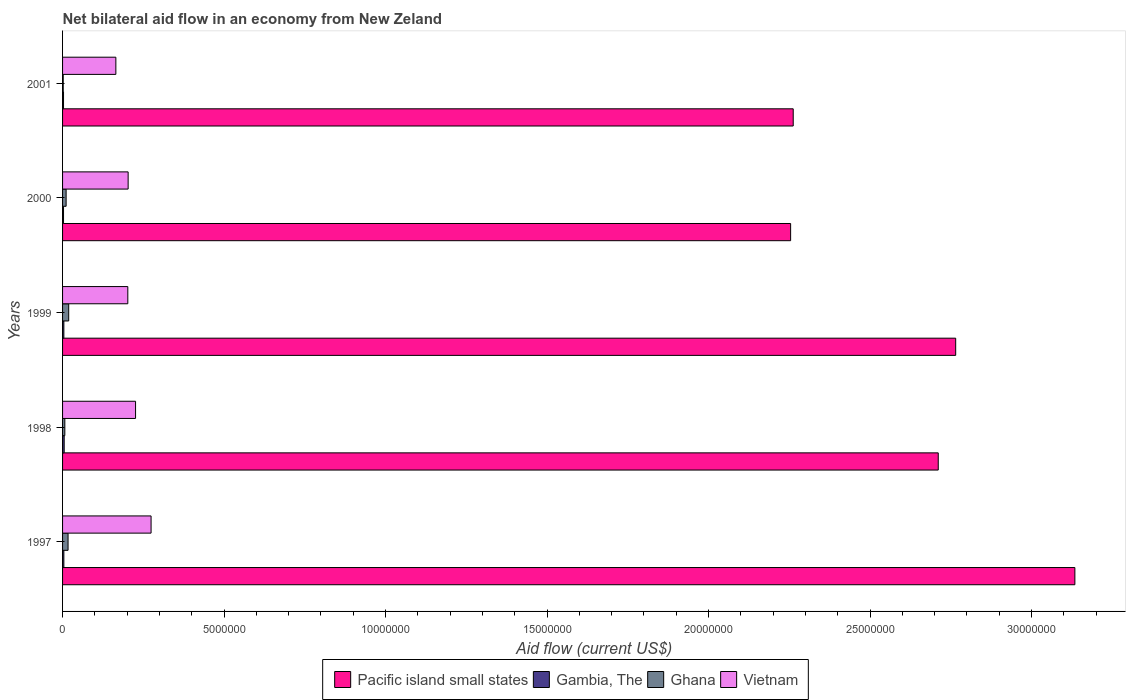How many different coloured bars are there?
Your answer should be very brief. 4. How many groups of bars are there?
Provide a succinct answer. 5. Are the number of bars on each tick of the Y-axis equal?
Offer a terse response. Yes. How many bars are there on the 3rd tick from the top?
Ensure brevity in your answer.  4. In how many cases, is the number of bars for a given year not equal to the number of legend labels?
Provide a short and direct response. 0. What is the net bilateral aid flow in Ghana in 1998?
Provide a short and direct response. 7.00e+04. Across all years, what is the maximum net bilateral aid flow in Vietnam?
Ensure brevity in your answer.  2.74e+06. Across all years, what is the minimum net bilateral aid flow in Pacific island small states?
Provide a short and direct response. 2.25e+07. In which year was the net bilateral aid flow in Ghana maximum?
Ensure brevity in your answer.  1999. What is the total net bilateral aid flow in Vietnam in the graph?
Provide a short and direct response. 1.07e+07. What is the difference between the net bilateral aid flow in Vietnam in 1998 and that in 1999?
Provide a succinct answer. 2.40e+05. What is the difference between the net bilateral aid flow in Pacific island small states in 2000 and the net bilateral aid flow in Vietnam in 1997?
Your answer should be compact. 1.98e+07. What is the average net bilateral aid flow in Pacific island small states per year?
Provide a succinct answer. 2.63e+07. In the year 1998, what is the difference between the net bilateral aid flow in Vietnam and net bilateral aid flow in Gambia, The?
Your response must be concise. 2.21e+06. In how many years, is the net bilateral aid flow in Pacific island small states greater than 21000000 US$?
Give a very brief answer. 5. What is the ratio of the net bilateral aid flow in Gambia, The in 1997 to that in 2001?
Ensure brevity in your answer.  1.33. Is the net bilateral aid flow in Pacific island small states in 1997 less than that in 2001?
Keep it short and to the point. No. What is the difference between the highest and the second highest net bilateral aid flow in Pacific island small states?
Keep it short and to the point. 3.69e+06. Is it the case that in every year, the sum of the net bilateral aid flow in Vietnam and net bilateral aid flow in Gambia, The is greater than the sum of net bilateral aid flow in Pacific island small states and net bilateral aid flow in Ghana?
Ensure brevity in your answer.  Yes. What does the 4th bar from the top in 2001 represents?
Ensure brevity in your answer.  Pacific island small states. What does the 1st bar from the bottom in 2001 represents?
Your answer should be compact. Pacific island small states. Is it the case that in every year, the sum of the net bilateral aid flow in Ghana and net bilateral aid flow in Vietnam is greater than the net bilateral aid flow in Pacific island small states?
Provide a short and direct response. No. How many bars are there?
Offer a very short reply. 20. How many years are there in the graph?
Make the answer very short. 5. What is the difference between two consecutive major ticks on the X-axis?
Your answer should be very brief. 5.00e+06. Does the graph contain grids?
Ensure brevity in your answer.  No. What is the title of the graph?
Your answer should be very brief. Net bilateral aid flow in an economy from New Zeland. Does "Lebanon" appear as one of the legend labels in the graph?
Provide a short and direct response. No. What is the label or title of the X-axis?
Your answer should be compact. Aid flow (current US$). What is the Aid flow (current US$) of Pacific island small states in 1997?
Keep it short and to the point. 3.13e+07. What is the Aid flow (current US$) in Ghana in 1997?
Make the answer very short. 1.70e+05. What is the Aid flow (current US$) in Vietnam in 1997?
Keep it short and to the point. 2.74e+06. What is the Aid flow (current US$) of Pacific island small states in 1998?
Your response must be concise. 2.71e+07. What is the Aid flow (current US$) in Gambia, The in 1998?
Provide a short and direct response. 5.00e+04. What is the Aid flow (current US$) in Ghana in 1998?
Give a very brief answer. 7.00e+04. What is the Aid flow (current US$) in Vietnam in 1998?
Keep it short and to the point. 2.26e+06. What is the Aid flow (current US$) of Pacific island small states in 1999?
Provide a succinct answer. 2.76e+07. What is the Aid flow (current US$) in Ghana in 1999?
Provide a short and direct response. 1.90e+05. What is the Aid flow (current US$) in Vietnam in 1999?
Your response must be concise. 2.02e+06. What is the Aid flow (current US$) in Pacific island small states in 2000?
Give a very brief answer. 2.25e+07. What is the Aid flow (current US$) of Gambia, The in 2000?
Give a very brief answer. 3.00e+04. What is the Aid flow (current US$) in Ghana in 2000?
Make the answer very short. 1.10e+05. What is the Aid flow (current US$) of Vietnam in 2000?
Provide a short and direct response. 2.03e+06. What is the Aid flow (current US$) of Pacific island small states in 2001?
Your answer should be very brief. 2.26e+07. What is the Aid flow (current US$) of Gambia, The in 2001?
Make the answer very short. 3.00e+04. What is the Aid flow (current US$) of Vietnam in 2001?
Provide a succinct answer. 1.65e+06. Across all years, what is the maximum Aid flow (current US$) in Pacific island small states?
Keep it short and to the point. 3.13e+07. Across all years, what is the maximum Aid flow (current US$) in Gambia, The?
Your answer should be compact. 5.00e+04. Across all years, what is the maximum Aid flow (current US$) of Vietnam?
Ensure brevity in your answer.  2.74e+06. Across all years, what is the minimum Aid flow (current US$) of Pacific island small states?
Provide a short and direct response. 2.25e+07. Across all years, what is the minimum Aid flow (current US$) of Gambia, The?
Ensure brevity in your answer.  3.00e+04. Across all years, what is the minimum Aid flow (current US$) of Ghana?
Keep it short and to the point. 2.00e+04. Across all years, what is the minimum Aid flow (current US$) of Vietnam?
Your answer should be very brief. 1.65e+06. What is the total Aid flow (current US$) of Pacific island small states in the graph?
Offer a very short reply. 1.31e+08. What is the total Aid flow (current US$) of Ghana in the graph?
Your answer should be very brief. 5.60e+05. What is the total Aid flow (current US$) of Vietnam in the graph?
Provide a succinct answer. 1.07e+07. What is the difference between the Aid flow (current US$) in Pacific island small states in 1997 and that in 1998?
Give a very brief answer. 4.23e+06. What is the difference between the Aid flow (current US$) in Gambia, The in 1997 and that in 1998?
Give a very brief answer. -10000. What is the difference between the Aid flow (current US$) in Vietnam in 1997 and that in 1998?
Your answer should be compact. 4.80e+05. What is the difference between the Aid flow (current US$) in Pacific island small states in 1997 and that in 1999?
Your response must be concise. 3.69e+06. What is the difference between the Aid flow (current US$) in Vietnam in 1997 and that in 1999?
Make the answer very short. 7.20e+05. What is the difference between the Aid flow (current US$) in Pacific island small states in 1997 and that in 2000?
Make the answer very short. 8.80e+06. What is the difference between the Aid flow (current US$) in Ghana in 1997 and that in 2000?
Give a very brief answer. 6.00e+04. What is the difference between the Aid flow (current US$) in Vietnam in 1997 and that in 2000?
Provide a succinct answer. 7.10e+05. What is the difference between the Aid flow (current US$) of Pacific island small states in 1997 and that in 2001?
Make the answer very short. 8.72e+06. What is the difference between the Aid flow (current US$) in Gambia, The in 1997 and that in 2001?
Offer a very short reply. 10000. What is the difference between the Aid flow (current US$) in Ghana in 1997 and that in 2001?
Give a very brief answer. 1.50e+05. What is the difference between the Aid flow (current US$) in Vietnam in 1997 and that in 2001?
Offer a very short reply. 1.09e+06. What is the difference between the Aid flow (current US$) of Pacific island small states in 1998 and that in 1999?
Make the answer very short. -5.40e+05. What is the difference between the Aid flow (current US$) in Pacific island small states in 1998 and that in 2000?
Ensure brevity in your answer.  4.57e+06. What is the difference between the Aid flow (current US$) in Gambia, The in 1998 and that in 2000?
Your response must be concise. 2.00e+04. What is the difference between the Aid flow (current US$) in Vietnam in 1998 and that in 2000?
Your answer should be compact. 2.30e+05. What is the difference between the Aid flow (current US$) of Pacific island small states in 1998 and that in 2001?
Offer a very short reply. 4.49e+06. What is the difference between the Aid flow (current US$) in Gambia, The in 1998 and that in 2001?
Make the answer very short. 2.00e+04. What is the difference between the Aid flow (current US$) of Ghana in 1998 and that in 2001?
Give a very brief answer. 5.00e+04. What is the difference between the Aid flow (current US$) of Pacific island small states in 1999 and that in 2000?
Your answer should be very brief. 5.11e+06. What is the difference between the Aid flow (current US$) of Ghana in 1999 and that in 2000?
Give a very brief answer. 8.00e+04. What is the difference between the Aid flow (current US$) in Vietnam in 1999 and that in 2000?
Offer a very short reply. -10000. What is the difference between the Aid flow (current US$) of Pacific island small states in 1999 and that in 2001?
Make the answer very short. 5.03e+06. What is the difference between the Aid flow (current US$) in Gambia, The in 1999 and that in 2001?
Offer a very short reply. 10000. What is the difference between the Aid flow (current US$) of Vietnam in 1999 and that in 2001?
Offer a terse response. 3.70e+05. What is the difference between the Aid flow (current US$) in Gambia, The in 2000 and that in 2001?
Your answer should be very brief. 0. What is the difference between the Aid flow (current US$) of Ghana in 2000 and that in 2001?
Your answer should be very brief. 9.00e+04. What is the difference between the Aid flow (current US$) of Pacific island small states in 1997 and the Aid flow (current US$) of Gambia, The in 1998?
Ensure brevity in your answer.  3.13e+07. What is the difference between the Aid flow (current US$) of Pacific island small states in 1997 and the Aid flow (current US$) of Ghana in 1998?
Provide a succinct answer. 3.13e+07. What is the difference between the Aid flow (current US$) of Pacific island small states in 1997 and the Aid flow (current US$) of Vietnam in 1998?
Keep it short and to the point. 2.91e+07. What is the difference between the Aid flow (current US$) of Gambia, The in 1997 and the Aid flow (current US$) of Vietnam in 1998?
Keep it short and to the point. -2.22e+06. What is the difference between the Aid flow (current US$) of Ghana in 1997 and the Aid flow (current US$) of Vietnam in 1998?
Give a very brief answer. -2.09e+06. What is the difference between the Aid flow (current US$) of Pacific island small states in 1997 and the Aid flow (current US$) of Gambia, The in 1999?
Your answer should be compact. 3.13e+07. What is the difference between the Aid flow (current US$) of Pacific island small states in 1997 and the Aid flow (current US$) of Ghana in 1999?
Provide a short and direct response. 3.12e+07. What is the difference between the Aid flow (current US$) in Pacific island small states in 1997 and the Aid flow (current US$) in Vietnam in 1999?
Keep it short and to the point. 2.93e+07. What is the difference between the Aid flow (current US$) in Gambia, The in 1997 and the Aid flow (current US$) in Vietnam in 1999?
Your response must be concise. -1.98e+06. What is the difference between the Aid flow (current US$) of Ghana in 1997 and the Aid flow (current US$) of Vietnam in 1999?
Give a very brief answer. -1.85e+06. What is the difference between the Aid flow (current US$) in Pacific island small states in 1997 and the Aid flow (current US$) in Gambia, The in 2000?
Your answer should be compact. 3.13e+07. What is the difference between the Aid flow (current US$) of Pacific island small states in 1997 and the Aid flow (current US$) of Ghana in 2000?
Give a very brief answer. 3.12e+07. What is the difference between the Aid flow (current US$) of Pacific island small states in 1997 and the Aid flow (current US$) of Vietnam in 2000?
Keep it short and to the point. 2.93e+07. What is the difference between the Aid flow (current US$) in Gambia, The in 1997 and the Aid flow (current US$) in Vietnam in 2000?
Ensure brevity in your answer.  -1.99e+06. What is the difference between the Aid flow (current US$) in Ghana in 1997 and the Aid flow (current US$) in Vietnam in 2000?
Give a very brief answer. -1.86e+06. What is the difference between the Aid flow (current US$) in Pacific island small states in 1997 and the Aid flow (current US$) in Gambia, The in 2001?
Provide a succinct answer. 3.13e+07. What is the difference between the Aid flow (current US$) in Pacific island small states in 1997 and the Aid flow (current US$) in Ghana in 2001?
Offer a very short reply. 3.13e+07. What is the difference between the Aid flow (current US$) of Pacific island small states in 1997 and the Aid flow (current US$) of Vietnam in 2001?
Offer a terse response. 2.97e+07. What is the difference between the Aid flow (current US$) of Gambia, The in 1997 and the Aid flow (current US$) of Vietnam in 2001?
Offer a terse response. -1.61e+06. What is the difference between the Aid flow (current US$) in Ghana in 1997 and the Aid flow (current US$) in Vietnam in 2001?
Provide a short and direct response. -1.48e+06. What is the difference between the Aid flow (current US$) in Pacific island small states in 1998 and the Aid flow (current US$) in Gambia, The in 1999?
Your response must be concise. 2.71e+07. What is the difference between the Aid flow (current US$) in Pacific island small states in 1998 and the Aid flow (current US$) in Ghana in 1999?
Provide a short and direct response. 2.69e+07. What is the difference between the Aid flow (current US$) in Pacific island small states in 1998 and the Aid flow (current US$) in Vietnam in 1999?
Provide a short and direct response. 2.51e+07. What is the difference between the Aid flow (current US$) in Gambia, The in 1998 and the Aid flow (current US$) in Vietnam in 1999?
Keep it short and to the point. -1.97e+06. What is the difference between the Aid flow (current US$) in Ghana in 1998 and the Aid flow (current US$) in Vietnam in 1999?
Offer a terse response. -1.95e+06. What is the difference between the Aid flow (current US$) of Pacific island small states in 1998 and the Aid flow (current US$) of Gambia, The in 2000?
Provide a succinct answer. 2.71e+07. What is the difference between the Aid flow (current US$) in Pacific island small states in 1998 and the Aid flow (current US$) in Ghana in 2000?
Your answer should be very brief. 2.70e+07. What is the difference between the Aid flow (current US$) in Pacific island small states in 1998 and the Aid flow (current US$) in Vietnam in 2000?
Keep it short and to the point. 2.51e+07. What is the difference between the Aid flow (current US$) in Gambia, The in 1998 and the Aid flow (current US$) in Vietnam in 2000?
Your answer should be compact. -1.98e+06. What is the difference between the Aid flow (current US$) of Ghana in 1998 and the Aid flow (current US$) of Vietnam in 2000?
Offer a terse response. -1.96e+06. What is the difference between the Aid flow (current US$) in Pacific island small states in 1998 and the Aid flow (current US$) in Gambia, The in 2001?
Keep it short and to the point. 2.71e+07. What is the difference between the Aid flow (current US$) of Pacific island small states in 1998 and the Aid flow (current US$) of Ghana in 2001?
Provide a short and direct response. 2.71e+07. What is the difference between the Aid flow (current US$) of Pacific island small states in 1998 and the Aid flow (current US$) of Vietnam in 2001?
Your answer should be very brief. 2.55e+07. What is the difference between the Aid flow (current US$) of Gambia, The in 1998 and the Aid flow (current US$) of Vietnam in 2001?
Make the answer very short. -1.60e+06. What is the difference between the Aid flow (current US$) of Ghana in 1998 and the Aid flow (current US$) of Vietnam in 2001?
Ensure brevity in your answer.  -1.58e+06. What is the difference between the Aid flow (current US$) in Pacific island small states in 1999 and the Aid flow (current US$) in Gambia, The in 2000?
Provide a succinct answer. 2.76e+07. What is the difference between the Aid flow (current US$) of Pacific island small states in 1999 and the Aid flow (current US$) of Ghana in 2000?
Your answer should be compact. 2.75e+07. What is the difference between the Aid flow (current US$) of Pacific island small states in 1999 and the Aid flow (current US$) of Vietnam in 2000?
Provide a short and direct response. 2.56e+07. What is the difference between the Aid flow (current US$) of Gambia, The in 1999 and the Aid flow (current US$) of Ghana in 2000?
Provide a short and direct response. -7.00e+04. What is the difference between the Aid flow (current US$) of Gambia, The in 1999 and the Aid flow (current US$) of Vietnam in 2000?
Offer a very short reply. -1.99e+06. What is the difference between the Aid flow (current US$) of Ghana in 1999 and the Aid flow (current US$) of Vietnam in 2000?
Make the answer very short. -1.84e+06. What is the difference between the Aid flow (current US$) of Pacific island small states in 1999 and the Aid flow (current US$) of Gambia, The in 2001?
Your answer should be compact. 2.76e+07. What is the difference between the Aid flow (current US$) of Pacific island small states in 1999 and the Aid flow (current US$) of Ghana in 2001?
Keep it short and to the point. 2.76e+07. What is the difference between the Aid flow (current US$) in Pacific island small states in 1999 and the Aid flow (current US$) in Vietnam in 2001?
Offer a very short reply. 2.60e+07. What is the difference between the Aid flow (current US$) of Gambia, The in 1999 and the Aid flow (current US$) of Vietnam in 2001?
Provide a succinct answer. -1.61e+06. What is the difference between the Aid flow (current US$) of Ghana in 1999 and the Aid flow (current US$) of Vietnam in 2001?
Your answer should be compact. -1.46e+06. What is the difference between the Aid flow (current US$) in Pacific island small states in 2000 and the Aid flow (current US$) in Gambia, The in 2001?
Ensure brevity in your answer.  2.25e+07. What is the difference between the Aid flow (current US$) in Pacific island small states in 2000 and the Aid flow (current US$) in Ghana in 2001?
Provide a short and direct response. 2.25e+07. What is the difference between the Aid flow (current US$) in Pacific island small states in 2000 and the Aid flow (current US$) in Vietnam in 2001?
Provide a succinct answer. 2.09e+07. What is the difference between the Aid flow (current US$) in Gambia, The in 2000 and the Aid flow (current US$) in Ghana in 2001?
Keep it short and to the point. 10000. What is the difference between the Aid flow (current US$) in Gambia, The in 2000 and the Aid flow (current US$) in Vietnam in 2001?
Your answer should be very brief. -1.62e+06. What is the difference between the Aid flow (current US$) of Ghana in 2000 and the Aid flow (current US$) of Vietnam in 2001?
Ensure brevity in your answer.  -1.54e+06. What is the average Aid flow (current US$) of Pacific island small states per year?
Offer a terse response. 2.63e+07. What is the average Aid flow (current US$) of Gambia, The per year?
Your answer should be compact. 3.80e+04. What is the average Aid flow (current US$) of Ghana per year?
Your response must be concise. 1.12e+05. What is the average Aid flow (current US$) of Vietnam per year?
Offer a terse response. 2.14e+06. In the year 1997, what is the difference between the Aid flow (current US$) of Pacific island small states and Aid flow (current US$) of Gambia, The?
Your response must be concise. 3.13e+07. In the year 1997, what is the difference between the Aid flow (current US$) in Pacific island small states and Aid flow (current US$) in Ghana?
Give a very brief answer. 3.12e+07. In the year 1997, what is the difference between the Aid flow (current US$) of Pacific island small states and Aid flow (current US$) of Vietnam?
Make the answer very short. 2.86e+07. In the year 1997, what is the difference between the Aid flow (current US$) in Gambia, The and Aid flow (current US$) in Vietnam?
Keep it short and to the point. -2.70e+06. In the year 1997, what is the difference between the Aid flow (current US$) of Ghana and Aid flow (current US$) of Vietnam?
Provide a succinct answer. -2.57e+06. In the year 1998, what is the difference between the Aid flow (current US$) in Pacific island small states and Aid flow (current US$) in Gambia, The?
Offer a terse response. 2.71e+07. In the year 1998, what is the difference between the Aid flow (current US$) in Pacific island small states and Aid flow (current US$) in Ghana?
Offer a terse response. 2.70e+07. In the year 1998, what is the difference between the Aid flow (current US$) of Pacific island small states and Aid flow (current US$) of Vietnam?
Your response must be concise. 2.48e+07. In the year 1998, what is the difference between the Aid flow (current US$) of Gambia, The and Aid flow (current US$) of Vietnam?
Make the answer very short. -2.21e+06. In the year 1998, what is the difference between the Aid flow (current US$) of Ghana and Aid flow (current US$) of Vietnam?
Provide a succinct answer. -2.19e+06. In the year 1999, what is the difference between the Aid flow (current US$) of Pacific island small states and Aid flow (current US$) of Gambia, The?
Ensure brevity in your answer.  2.76e+07. In the year 1999, what is the difference between the Aid flow (current US$) of Pacific island small states and Aid flow (current US$) of Ghana?
Provide a short and direct response. 2.75e+07. In the year 1999, what is the difference between the Aid flow (current US$) in Pacific island small states and Aid flow (current US$) in Vietnam?
Provide a succinct answer. 2.56e+07. In the year 1999, what is the difference between the Aid flow (current US$) in Gambia, The and Aid flow (current US$) in Vietnam?
Make the answer very short. -1.98e+06. In the year 1999, what is the difference between the Aid flow (current US$) of Ghana and Aid flow (current US$) of Vietnam?
Give a very brief answer. -1.83e+06. In the year 2000, what is the difference between the Aid flow (current US$) in Pacific island small states and Aid flow (current US$) in Gambia, The?
Provide a succinct answer. 2.25e+07. In the year 2000, what is the difference between the Aid flow (current US$) of Pacific island small states and Aid flow (current US$) of Ghana?
Ensure brevity in your answer.  2.24e+07. In the year 2000, what is the difference between the Aid flow (current US$) of Pacific island small states and Aid flow (current US$) of Vietnam?
Give a very brief answer. 2.05e+07. In the year 2000, what is the difference between the Aid flow (current US$) of Gambia, The and Aid flow (current US$) of Ghana?
Ensure brevity in your answer.  -8.00e+04. In the year 2000, what is the difference between the Aid flow (current US$) of Gambia, The and Aid flow (current US$) of Vietnam?
Your response must be concise. -2.00e+06. In the year 2000, what is the difference between the Aid flow (current US$) of Ghana and Aid flow (current US$) of Vietnam?
Offer a very short reply. -1.92e+06. In the year 2001, what is the difference between the Aid flow (current US$) of Pacific island small states and Aid flow (current US$) of Gambia, The?
Offer a terse response. 2.26e+07. In the year 2001, what is the difference between the Aid flow (current US$) of Pacific island small states and Aid flow (current US$) of Ghana?
Offer a terse response. 2.26e+07. In the year 2001, what is the difference between the Aid flow (current US$) of Pacific island small states and Aid flow (current US$) of Vietnam?
Offer a very short reply. 2.10e+07. In the year 2001, what is the difference between the Aid flow (current US$) in Gambia, The and Aid flow (current US$) in Ghana?
Provide a short and direct response. 10000. In the year 2001, what is the difference between the Aid flow (current US$) in Gambia, The and Aid flow (current US$) in Vietnam?
Keep it short and to the point. -1.62e+06. In the year 2001, what is the difference between the Aid flow (current US$) of Ghana and Aid flow (current US$) of Vietnam?
Your answer should be compact. -1.63e+06. What is the ratio of the Aid flow (current US$) in Pacific island small states in 1997 to that in 1998?
Offer a terse response. 1.16. What is the ratio of the Aid flow (current US$) in Ghana in 1997 to that in 1998?
Make the answer very short. 2.43. What is the ratio of the Aid flow (current US$) in Vietnam in 1997 to that in 1998?
Offer a very short reply. 1.21. What is the ratio of the Aid flow (current US$) of Pacific island small states in 1997 to that in 1999?
Give a very brief answer. 1.13. What is the ratio of the Aid flow (current US$) of Gambia, The in 1997 to that in 1999?
Make the answer very short. 1. What is the ratio of the Aid flow (current US$) in Ghana in 1997 to that in 1999?
Provide a succinct answer. 0.89. What is the ratio of the Aid flow (current US$) in Vietnam in 1997 to that in 1999?
Give a very brief answer. 1.36. What is the ratio of the Aid flow (current US$) of Pacific island small states in 1997 to that in 2000?
Your response must be concise. 1.39. What is the ratio of the Aid flow (current US$) of Ghana in 1997 to that in 2000?
Provide a short and direct response. 1.55. What is the ratio of the Aid flow (current US$) in Vietnam in 1997 to that in 2000?
Ensure brevity in your answer.  1.35. What is the ratio of the Aid flow (current US$) in Pacific island small states in 1997 to that in 2001?
Provide a short and direct response. 1.39. What is the ratio of the Aid flow (current US$) in Ghana in 1997 to that in 2001?
Provide a short and direct response. 8.5. What is the ratio of the Aid flow (current US$) of Vietnam in 1997 to that in 2001?
Give a very brief answer. 1.66. What is the ratio of the Aid flow (current US$) in Pacific island small states in 1998 to that in 1999?
Ensure brevity in your answer.  0.98. What is the ratio of the Aid flow (current US$) of Ghana in 1998 to that in 1999?
Ensure brevity in your answer.  0.37. What is the ratio of the Aid flow (current US$) of Vietnam in 1998 to that in 1999?
Your answer should be very brief. 1.12. What is the ratio of the Aid flow (current US$) of Pacific island small states in 1998 to that in 2000?
Give a very brief answer. 1.2. What is the ratio of the Aid flow (current US$) in Ghana in 1998 to that in 2000?
Offer a very short reply. 0.64. What is the ratio of the Aid flow (current US$) of Vietnam in 1998 to that in 2000?
Provide a succinct answer. 1.11. What is the ratio of the Aid flow (current US$) in Pacific island small states in 1998 to that in 2001?
Your answer should be compact. 1.2. What is the ratio of the Aid flow (current US$) in Ghana in 1998 to that in 2001?
Your answer should be very brief. 3.5. What is the ratio of the Aid flow (current US$) in Vietnam in 1998 to that in 2001?
Offer a very short reply. 1.37. What is the ratio of the Aid flow (current US$) in Pacific island small states in 1999 to that in 2000?
Your answer should be compact. 1.23. What is the ratio of the Aid flow (current US$) in Ghana in 1999 to that in 2000?
Make the answer very short. 1.73. What is the ratio of the Aid flow (current US$) of Vietnam in 1999 to that in 2000?
Your response must be concise. 1. What is the ratio of the Aid flow (current US$) in Pacific island small states in 1999 to that in 2001?
Provide a succinct answer. 1.22. What is the ratio of the Aid flow (current US$) of Gambia, The in 1999 to that in 2001?
Keep it short and to the point. 1.33. What is the ratio of the Aid flow (current US$) in Vietnam in 1999 to that in 2001?
Make the answer very short. 1.22. What is the ratio of the Aid flow (current US$) in Pacific island small states in 2000 to that in 2001?
Your answer should be very brief. 1. What is the ratio of the Aid flow (current US$) in Gambia, The in 2000 to that in 2001?
Ensure brevity in your answer.  1. What is the ratio of the Aid flow (current US$) of Vietnam in 2000 to that in 2001?
Give a very brief answer. 1.23. What is the difference between the highest and the second highest Aid flow (current US$) of Pacific island small states?
Make the answer very short. 3.69e+06. What is the difference between the highest and the second highest Aid flow (current US$) in Gambia, The?
Offer a terse response. 10000. What is the difference between the highest and the second highest Aid flow (current US$) in Ghana?
Provide a short and direct response. 2.00e+04. What is the difference between the highest and the second highest Aid flow (current US$) in Vietnam?
Offer a terse response. 4.80e+05. What is the difference between the highest and the lowest Aid flow (current US$) of Pacific island small states?
Your response must be concise. 8.80e+06. What is the difference between the highest and the lowest Aid flow (current US$) of Gambia, The?
Offer a very short reply. 2.00e+04. What is the difference between the highest and the lowest Aid flow (current US$) in Ghana?
Give a very brief answer. 1.70e+05. What is the difference between the highest and the lowest Aid flow (current US$) of Vietnam?
Offer a terse response. 1.09e+06. 